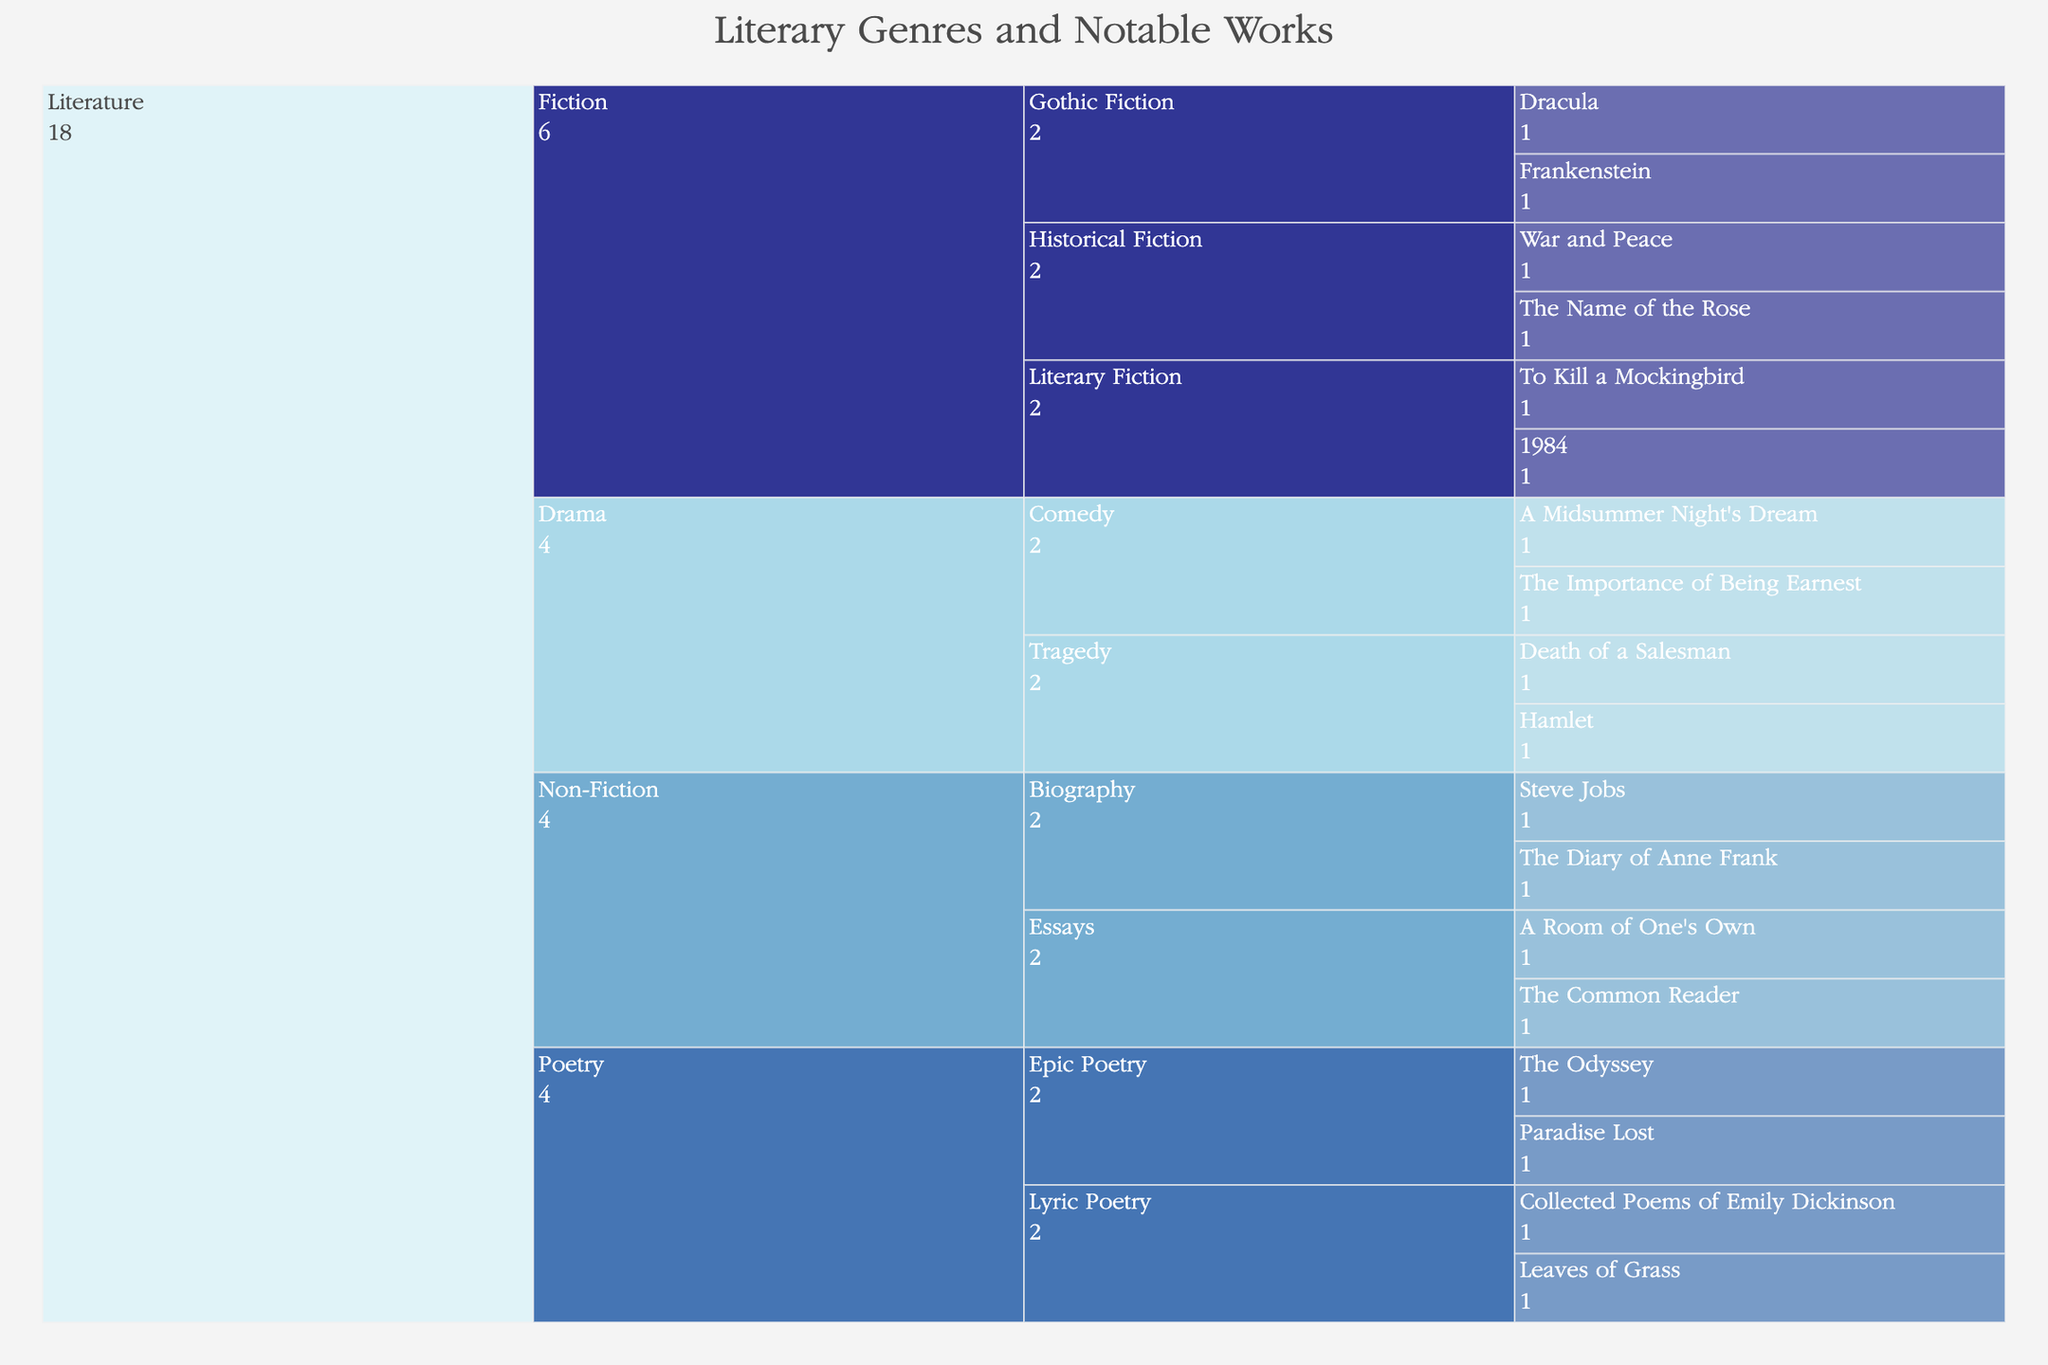What is the title of the figure? The title is usually displayed at the top of the chart. In this figure, it is visible as "Literary Genres and Notable Works".
Answer: Literary Genres and Notable Works In the Non-Fiction genre, which subgenres are listed? To find the subgenres listed under Non-Fiction, you need to look at the branches of the Icicle Chart starting from 'Non-Fiction' down to the next level. The subgenres listed are 'Biography' and 'Essays'.
Answer: Biography, Essays How many works are listed under the Poetry genre? To get the count of works under the Poetry genre, you need to identify all the terminal nodes branching from 'Poetry'. These are 'The Odyssey', 'Paradise Lost', 'Collected Poems of Emily Dickinson', and 'Leaves of Grass', totaling four works.
Answer: 4 Which genre has the most subgenres? To determine which genre has the most subgenres, look at the number of branches directly under each genre. The Fiction genre branches into 'Historical Fiction', 'Literary Fiction', and 'Gothic Fiction', making it the genre with the most subgenres (three).
Answer: Fiction How many works are listed under Drama, and what are they? To answer this, count the terminal nodes under 'Drama' and list their names. The works under Drama are 'Hamlet', 'Death of a Salesman', 'A Midsummer Night's Dream', and 'The Importance of Being Earnest', totaling four works.
Answer: 4, Hamlet, Death of a Salesman, A Midsummer Night's Dream, The Importance of Being Earnest Which subgenre in Fiction has the most works listed? To identify this, count the terminal nodes under each subgenre in Fiction. Historical Fiction has 'War and Peace' and 'The Name of the Rose' (2 works), Literary Fiction has 'To Kill a Mockingbird' and '1984' (2 works), and Gothic Fiction has 'Dracula' and 'Frankenstein' (2 works). Since all have the same number of works, it's a three-way tie.
Answer: Historical Fiction, Literary Fiction, Gothic Fiction (tie) Compare the number of works in Tragedy and Comedy within Drama. Which has more, and by how much? First, count the works under Tragedy and Comedy in Drama. Tragedy has 'Hamlet' and 'Death of a Salesman' (2 works), while Comedy has 'A Midsummer Night's Dream' and 'The Importance of Being Earnest' (2 works). Since both have the same number, there is no difference.
Answer: They have the same number, no difference What color scale is used in the figure? Observing the visual elements, particularly the hue changes, the color scale used in the figure is based on the diverging RdYlBu color palette.
Answer: RdYlBu Which works fall under the category of Epic Poetry? Look at the terminal nodes branching from 'Epic Poetry' under the Poetry genre. The works listed are 'The Odyssey' and 'Paradise Lost'.
Answer: The Odyssey, Paradise Lost 